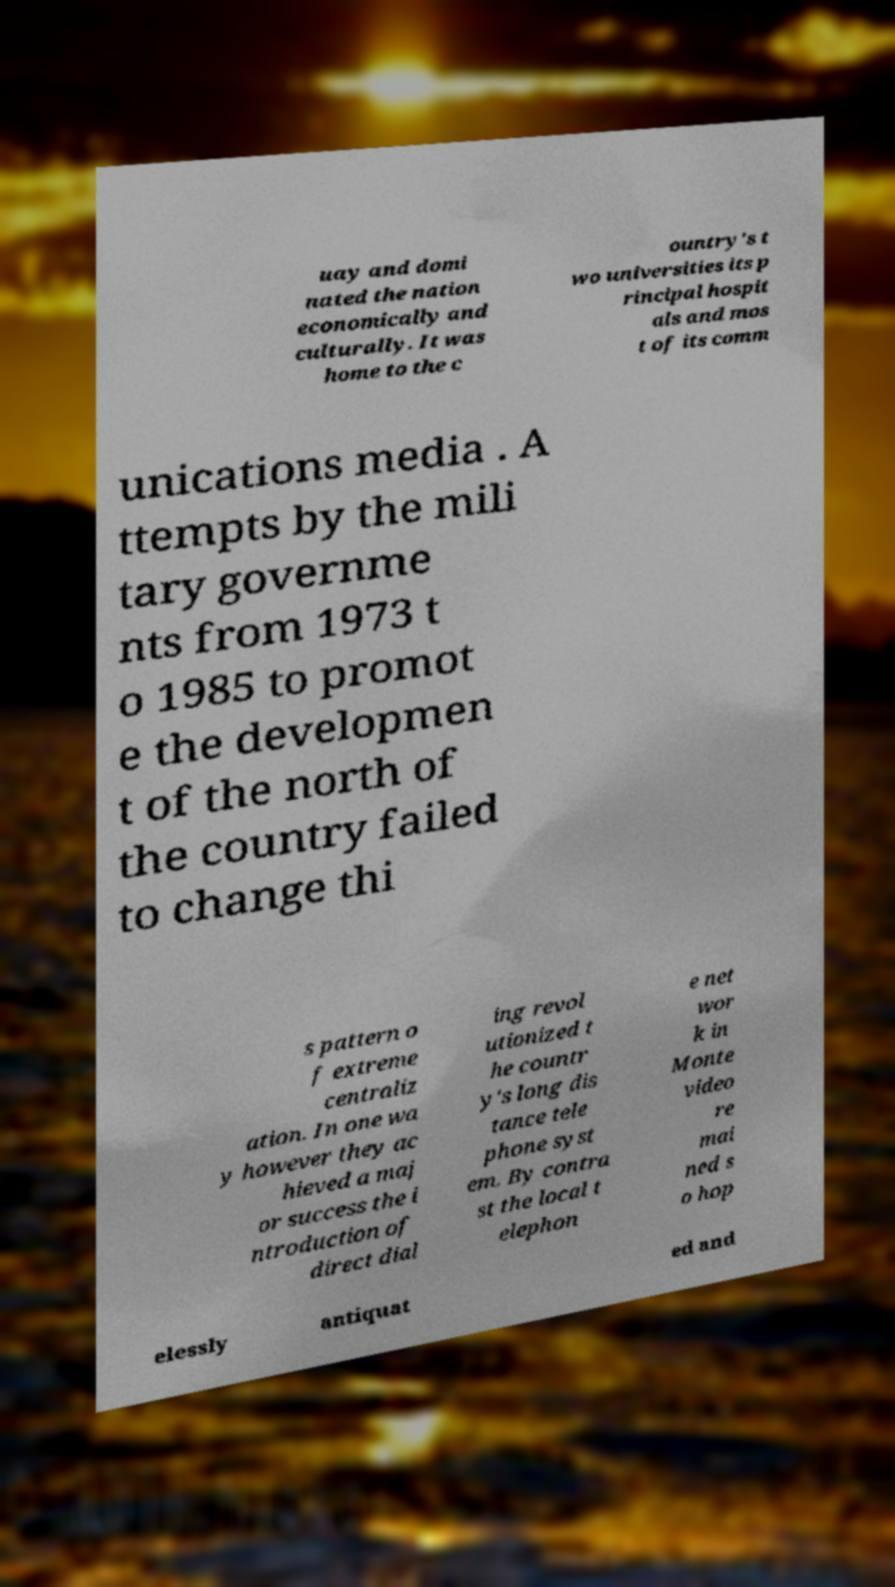Please identify and transcribe the text found in this image. uay and domi nated the nation economically and culturally. It was home to the c ountry's t wo universities its p rincipal hospit als and mos t of its comm unications media . A ttempts by the mili tary governme nts from 1973 t o 1985 to promot e the developmen t of the north of the country failed to change thi s pattern o f extreme centraliz ation. In one wa y however they ac hieved a maj or success the i ntroduction of direct dial ing revol utionized t he countr y's long dis tance tele phone syst em. By contra st the local t elephon e net wor k in Monte video re mai ned s o hop elessly antiquat ed and 